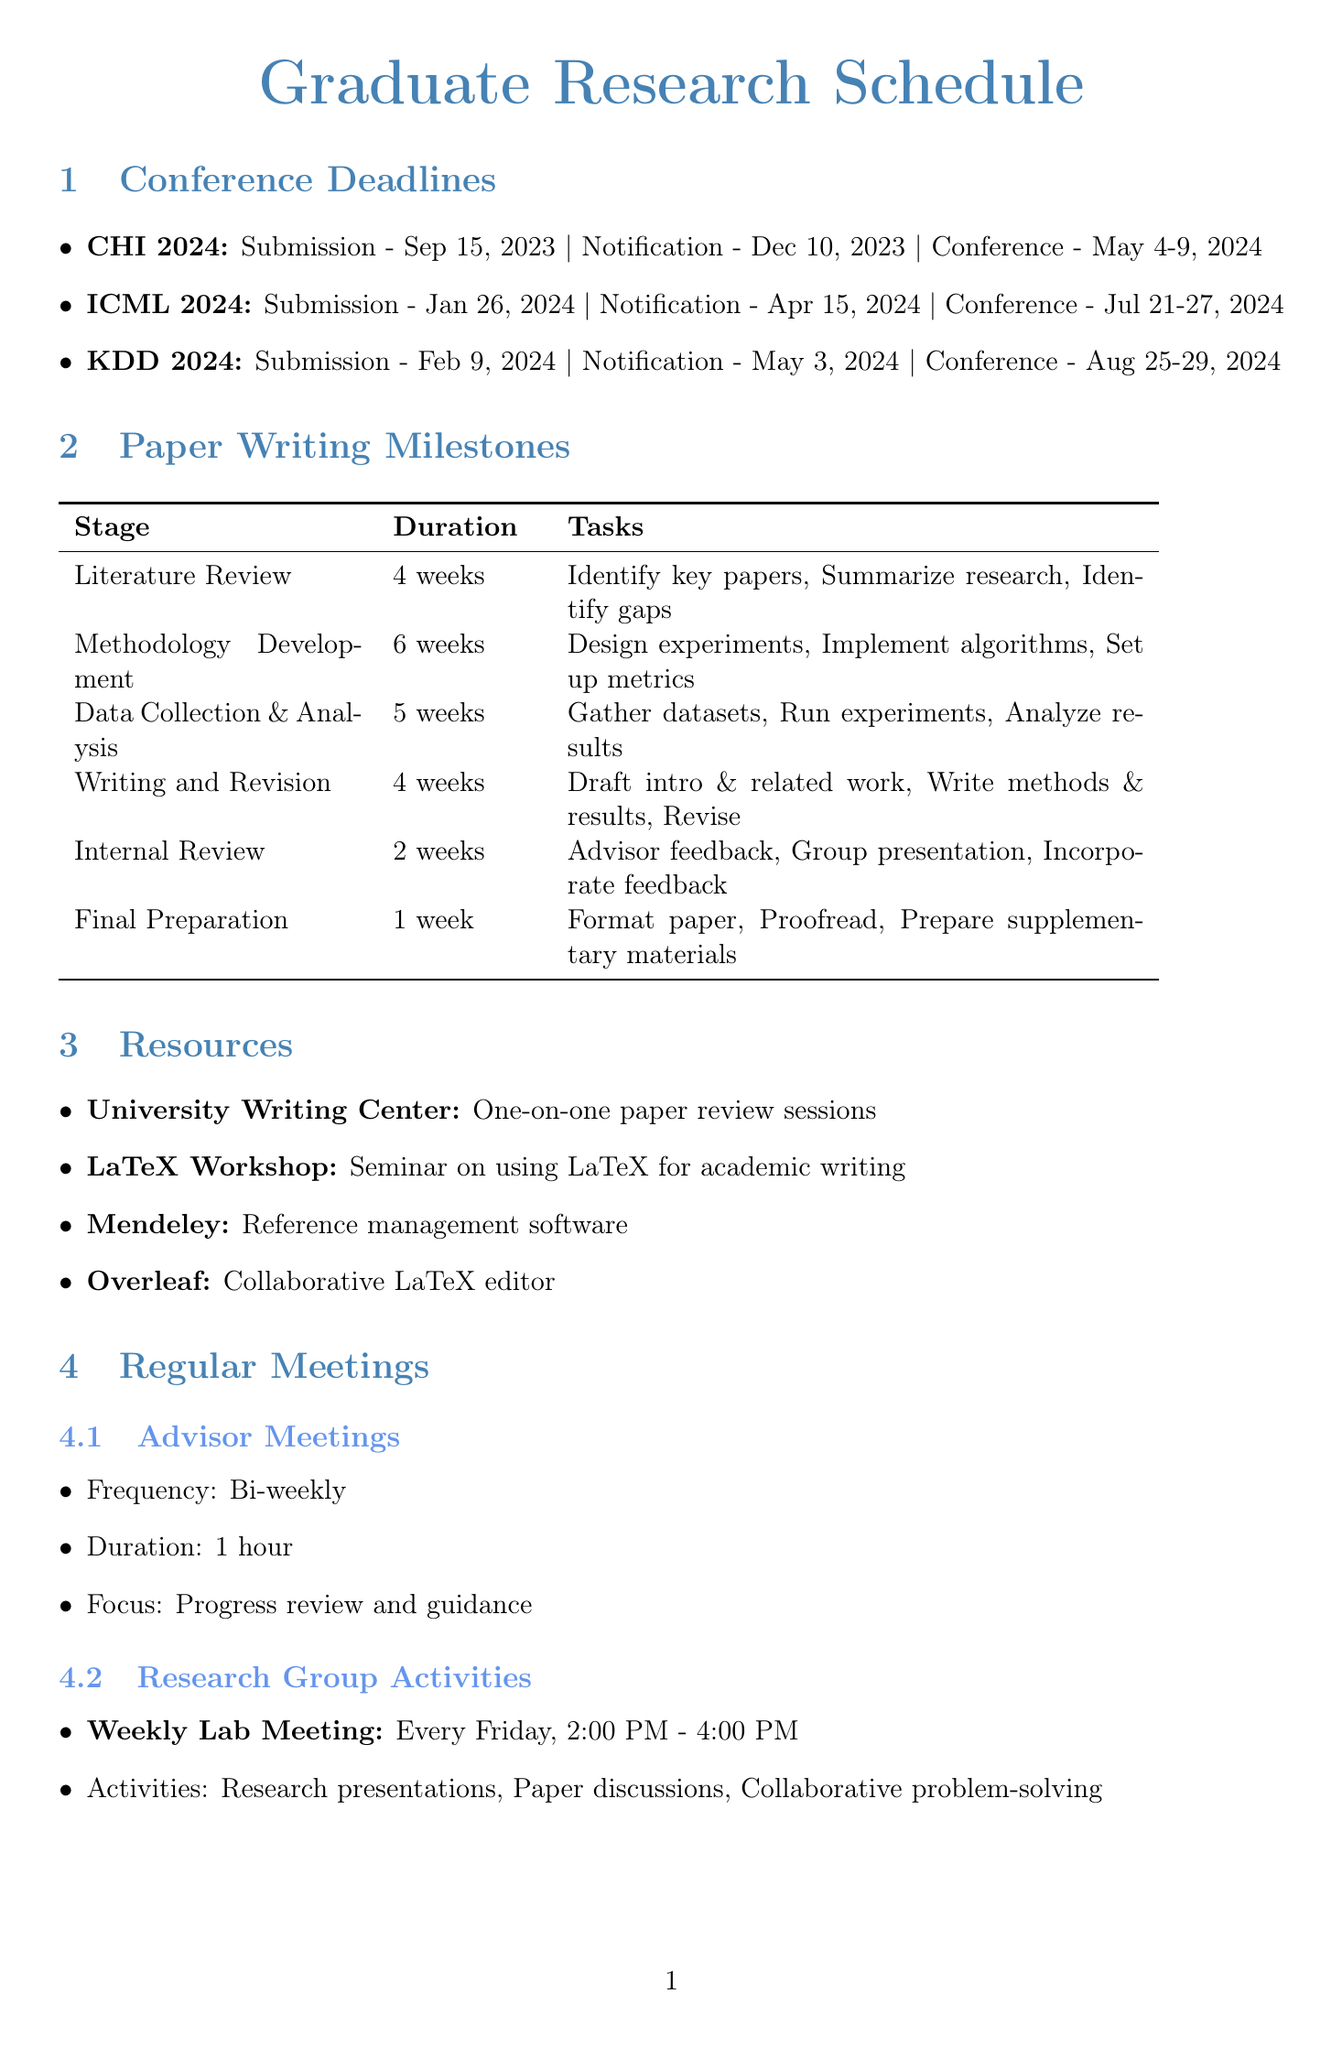What is the submission deadline for CHI 2024? The document states that the submission deadline for CHI 2024 is September 15, 2023.
Answer: September 15, 2023 When is the notification date for ICML 2024? The document specifies that the notification date for ICML 2024 is April 15, 2024.
Answer: April 15, 2024 How long is the Literature Review stage? The document indicates that the Literature Review stage lasts for 4 weeks.
Answer: 4 weeks What stage comes after Data Collection and Analysis? Based on the document, Writing and Revision follows Data Collection and Analysis.
Answer: Writing and Revision How many weeks are allocated for Final Preparation? The document states that Final Preparation is allocated 1 week.
Answer: 1 week What resources provide paper review sessions? The document mentions the University Writing Center as a resource that offers one-on-one paper review sessions.
Answer: University Writing Center What is the frequency of advisor meetings? According to the document, advisor meetings are scheduled bi-weekly.
Answer: Bi-weekly On which day are weekly lab meetings held? The document indicates that weekly lab meetings are held every Friday.
Answer: Every Friday What type of activities occur during the weekly lab meetings? The document lists research presentations, paper discussions, and collaborative problem-solving as the activities during the weekly lab meetings.
Answer: Research presentations, paper discussions, collaborative problem-solving 